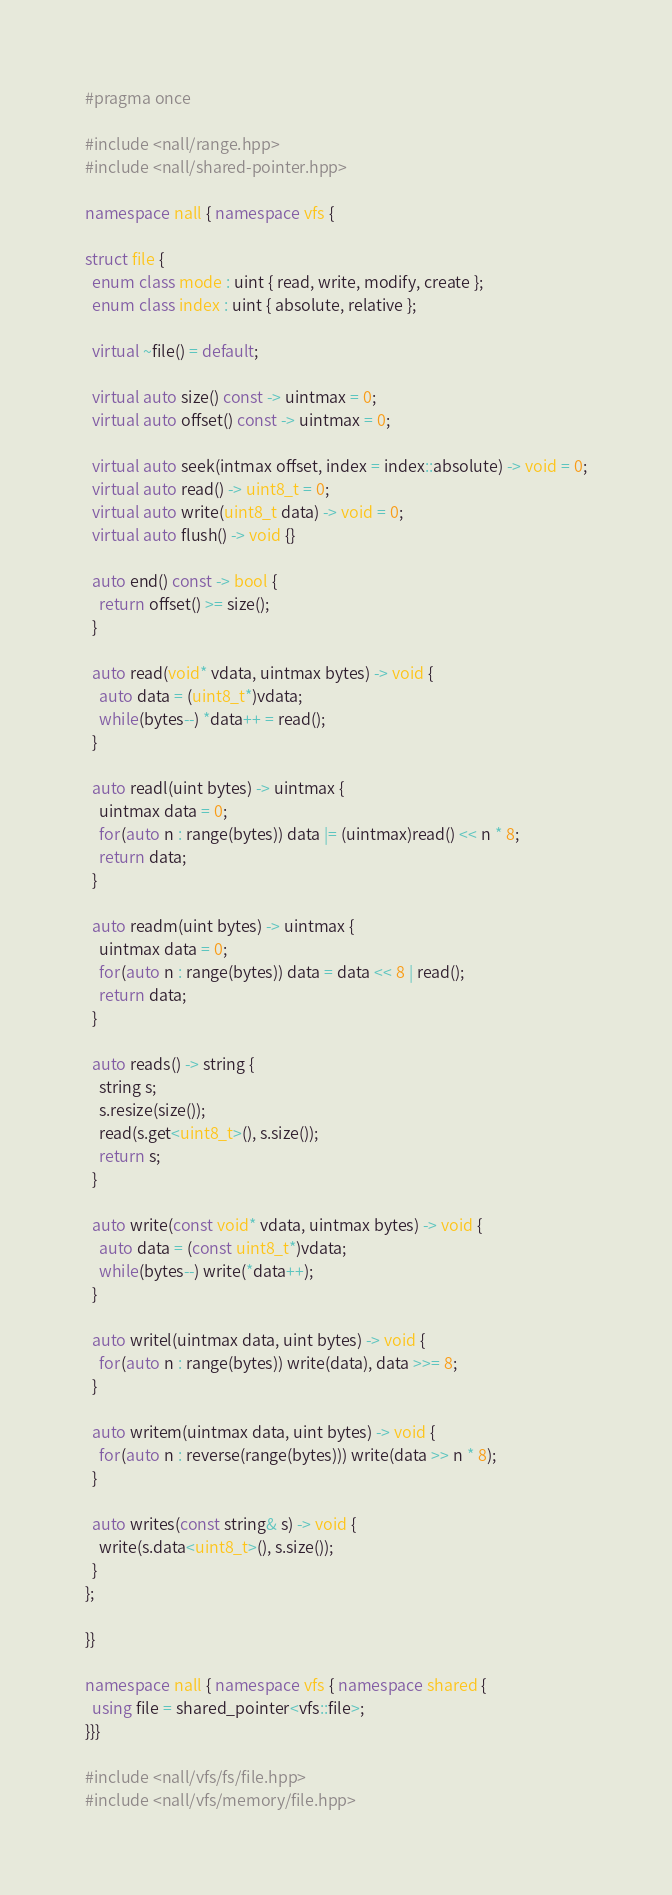<code> <loc_0><loc_0><loc_500><loc_500><_C++_>#pragma once

#include <nall/range.hpp>
#include <nall/shared-pointer.hpp>

namespace nall { namespace vfs {

struct file {
  enum class mode : uint { read, write, modify, create };
  enum class index : uint { absolute, relative };

  virtual ~file() = default;

  virtual auto size() const -> uintmax = 0;
  virtual auto offset() const -> uintmax = 0;

  virtual auto seek(intmax offset, index = index::absolute) -> void = 0;
  virtual auto read() -> uint8_t = 0;
  virtual auto write(uint8_t data) -> void = 0;
  virtual auto flush() -> void {}

  auto end() const -> bool {
    return offset() >= size();
  }

  auto read(void* vdata, uintmax bytes) -> void {
    auto data = (uint8_t*)vdata;
    while(bytes--) *data++ = read();
  }

  auto readl(uint bytes) -> uintmax {
    uintmax data = 0;
    for(auto n : range(bytes)) data |= (uintmax)read() << n * 8;
    return data;
  }

  auto readm(uint bytes) -> uintmax {
    uintmax data = 0;
    for(auto n : range(bytes)) data = data << 8 | read();
    return data;
  }

  auto reads() -> string {
    string s;
    s.resize(size());
    read(s.get<uint8_t>(), s.size());
    return s;
  }

  auto write(const void* vdata, uintmax bytes) -> void {
    auto data = (const uint8_t*)vdata;
    while(bytes--) write(*data++);
  }

  auto writel(uintmax data, uint bytes) -> void {
    for(auto n : range(bytes)) write(data), data >>= 8;
  }

  auto writem(uintmax data, uint bytes) -> void {
    for(auto n : reverse(range(bytes))) write(data >> n * 8);
  }

  auto writes(const string& s) -> void {
    write(s.data<uint8_t>(), s.size());
  }
};

}}

namespace nall { namespace vfs { namespace shared {
  using file = shared_pointer<vfs::file>;
}}}

#include <nall/vfs/fs/file.hpp>
#include <nall/vfs/memory/file.hpp>
</code> 